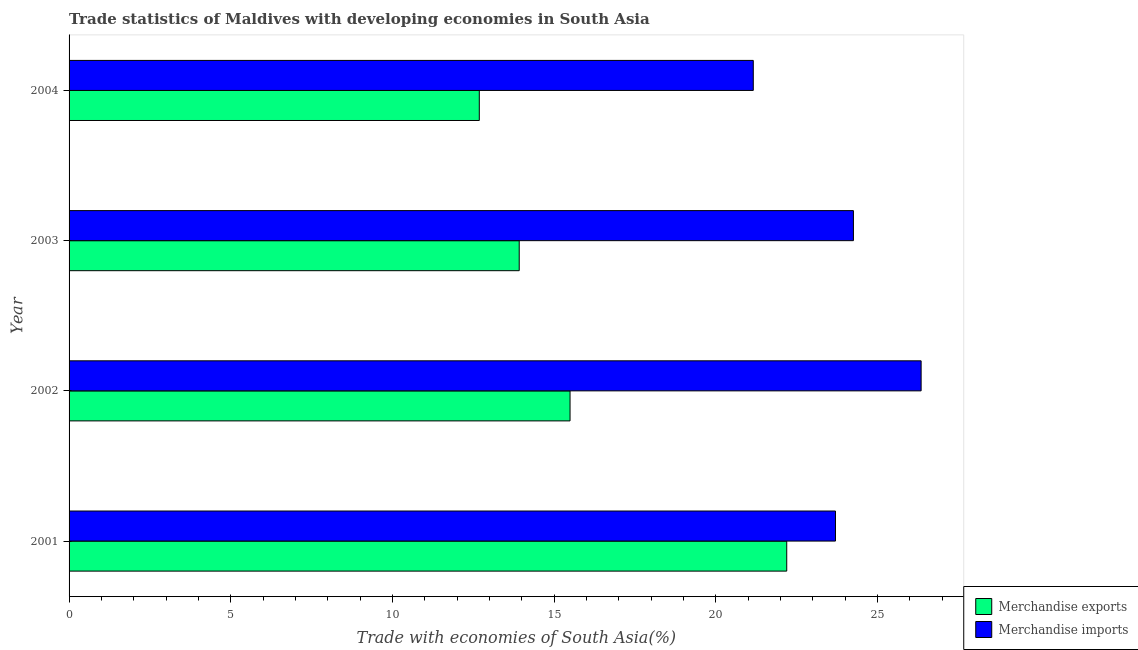How many groups of bars are there?
Provide a short and direct response. 4. Are the number of bars per tick equal to the number of legend labels?
Provide a succinct answer. Yes. Are the number of bars on each tick of the Y-axis equal?
Keep it short and to the point. Yes. How many bars are there on the 3rd tick from the top?
Your answer should be very brief. 2. How many bars are there on the 1st tick from the bottom?
Make the answer very short. 2. In how many cases, is the number of bars for a given year not equal to the number of legend labels?
Your response must be concise. 0. What is the merchandise exports in 2004?
Offer a terse response. 12.69. Across all years, what is the maximum merchandise exports?
Ensure brevity in your answer.  22.2. Across all years, what is the minimum merchandise exports?
Make the answer very short. 12.69. In which year was the merchandise imports maximum?
Make the answer very short. 2002. In which year was the merchandise exports minimum?
Your response must be concise. 2004. What is the total merchandise imports in the graph?
Provide a succinct answer. 95.48. What is the difference between the merchandise exports in 2003 and that in 2004?
Your response must be concise. 1.24. What is the difference between the merchandise exports in 2004 and the merchandise imports in 2001?
Your response must be concise. -11.02. What is the average merchandise exports per year?
Keep it short and to the point. 16.07. In the year 2004, what is the difference between the merchandise exports and merchandise imports?
Your response must be concise. -8.47. In how many years, is the merchandise exports greater than 21 %?
Your answer should be compact. 1. What is the ratio of the merchandise imports in 2002 to that in 2004?
Your response must be concise. 1.25. What is the difference between the highest and the second highest merchandise exports?
Offer a terse response. 6.7. What is the difference between the highest and the lowest merchandise imports?
Provide a short and direct response. 5.19. In how many years, is the merchandise imports greater than the average merchandise imports taken over all years?
Keep it short and to the point. 2. Is the sum of the merchandise imports in 2001 and 2003 greater than the maximum merchandise exports across all years?
Ensure brevity in your answer.  Yes. What does the 1st bar from the top in 2002 represents?
Your answer should be compact. Merchandise imports. What does the 1st bar from the bottom in 2001 represents?
Your response must be concise. Merchandise exports. What is the difference between two consecutive major ticks on the X-axis?
Ensure brevity in your answer.  5. Are the values on the major ticks of X-axis written in scientific E-notation?
Your answer should be compact. No. What is the title of the graph?
Keep it short and to the point. Trade statistics of Maldives with developing economies in South Asia. What is the label or title of the X-axis?
Offer a very short reply. Trade with economies of South Asia(%). What is the label or title of the Y-axis?
Ensure brevity in your answer.  Year. What is the Trade with economies of South Asia(%) of Merchandise exports in 2001?
Offer a very short reply. 22.2. What is the Trade with economies of South Asia(%) of Merchandise imports in 2001?
Ensure brevity in your answer.  23.7. What is the Trade with economies of South Asia(%) of Merchandise exports in 2002?
Keep it short and to the point. 15.49. What is the Trade with economies of South Asia(%) in Merchandise imports in 2002?
Your response must be concise. 26.35. What is the Trade with economies of South Asia(%) in Merchandise exports in 2003?
Offer a terse response. 13.92. What is the Trade with economies of South Asia(%) of Merchandise imports in 2003?
Your answer should be very brief. 24.26. What is the Trade with economies of South Asia(%) in Merchandise exports in 2004?
Your response must be concise. 12.69. What is the Trade with economies of South Asia(%) in Merchandise imports in 2004?
Give a very brief answer. 21.16. Across all years, what is the maximum Trade with economies of South Asia(%) in Merchandise exports?
Offer a terse response. 22.2. Across all years, what is the maximum Trade with economies of South Asia(%) in Merchandise imports?
Keep it short and to the point. 26.35. Across all years, what is the minimum Trade with economies of South Asia(%) of Merchandise exports?
Provide a short and direct response. 12.69. Across all years, what is the minimum Trade with economies of South Asia(%) of Merchandise imports?
Your answer should be very brief. 21.16. What is the total Trade with economies of South Asia(%) of Merchandise exports in the graph?
Your answer should be very brief. 64.3. What is the total Trade with economies of South Asia(%) in Merchandise imports in the graph?
Your response must be concise. 95.48. What is the difference between the Trade with economies of South Asia(%) in Merchandise exports in 2001 and that in 2002?
Ensure brevity in your answer.  6.7. What is the difference between the Trade with economies of South Asia(%) in Merchandise imports in 2001 and that in 2002?
Offer a terse response. -2.65. What is the difference between the Trade with economies of South Asia(%) of Merchandise exports in 2001 and that in 2003?
Make the answer very short. 8.27. What is the difference between the Trade with economies of South Asia(%) in Merchandise imports in 2001 and that in 2003?
Offer a very short reply. -0.56. What is the difference between the Trade with economies of South Asia(%) of Merchandise exports in 2001 and that in 2004?
Your answer should be very brief. 9.51. What is the difference between the Trade with economies of South Asia(%) of Merchandise imports in 2001 and that in 2004?
Offer a very short reply. 2.54. What is the difference between the Trade with economies of South Asia(%) of Merchandise exports in 2002 and that in 2003?
Keep it short and to the point. 1.57. What is the difference between the Trade with economies of South Asia(%) of Merchandise imports in 2002 and that in 2003?
Your response must be concise. 2.09. What is the difference between the Trade with economies of South Asia(%) of Merchandise exports in 2002 and that in 2004?
Ensure brevity in your answer.  2.81. What is the difference between the Trade with economies of South Asia(%) in Merchandise imports in 2002 and that in 2004?
Provide a short and direct response. 5.19. What is the difference between the Trade with economies of South Asia(%) of Merchandise exports in 2003 and that in 2004?
Keep it short and to the point. 1.23. What is the difference between the Trade with economies of South Asia(%) of Merchandise imports in 2003 and that in 2004?
Your answer should be very brief. 3.1. What is the difference between the Trade with economies of South Asia(%) in Merchandise exports in 2001 and the Trade with economies of South Asia(%) in Merchandise imports in 2002?
Your answer should be very brief. -4.16. What is the difference between the Trade with economies of South Asia(%) of Merchandise exports in 2001 and the Trade with economies of South Asia(%) of Merchandise imports in 2003?
Give a very brief answer. -2.06. What is the difference between the Trade with economies of South Asia(%) in Merchandise exports in 2001 and the Trade with economies of South Asia(%) in Merchandise imports in 2004?
Keep it short and to the point. 1.03. What is the difference between the Trade with economies of South Asia(%) in Merchandise exports in 2002 and the Trade with economies of South Asia(%) in Merchandise imports in 2003?
Your answer should be very brief. -8.76. What is the difference between the Trade with economies of South Asia(%) of Merchandise exports in 2002 and the Trade with economies of South Asia(%) of Merchandise imports in 2004?
Provide a succinct answer. -5.67. What is the difference between the Trade with economies of South Asia(%) of Merchandise exports in 2003 and the Trade with economies of South Asia(%) of Merchandise imports in 2004?
Make the answer very short. -7.24. What is the average Trade with economies of South Asia(%) of Merchandise exports per year?
Your answer should be compact. 16.08. What is the average Trade with economies of South Asia(%) in Merchandise imports per year?
Ensure brevity in your answer.  23.87. In the year 2001, what is the difference between the Trade with economies of South Asia(%) in Merchandise exports and Trade with economies of South Asia(%) in Merchandise imports?
Ensure brevity in your answer.  -1.51. In the year 2002, what is the difference between the Trade with economies of South Asia(%) of Merchandise exports and Trade with economies of South Asia(%) of Merchandise imports?
Your response must be concise. -10.86. In the year 2003, what is the difference between the Trade with economies of South Asia(%) in Merchandise exports and Trade with economies of South Asia(%) in Merchandise imports?
Your answer should be compact. -10.34. In the year 2004, what is the difference between the Trade with economies of South Asia(%) in Merchandise exports and Trade with economies of South Asia(%) in Merchandise imports?
Provide a succinct answer. -8.47. What is the ratio of the Trade with economies of South Asia(%) of Merchandise exports in 2001 to that in 2002?
Keep it short and to the point. 1.43. What is the ratio of the Trade with economies of South Asia(%) of Merchandise imports in 2001 to that in 2002?
Provide a short and direct response. 0.9. What is the ratio of the Trade with economies of South Asia(%) in Merchandise exports in 2001 to that in 2003?
Keep it short and to the point. 1.59. What is the ratio of the Trade with economies of South Asia(%) in Merchandise imports in 2001 to that in 2003?
Offer a terse response. 0.98. What is the ratio of the Trade with economies of South Asia(%) in Merchandise exports in 2001 to that in 2004?
Offer a very short reply. 1.75. What is the ratio of the Trade with economies of South Asia(%) in Merchandise imports in 2001 to that in 2004?
Provide a short and direct response. 1.12. What is the ratio of the Trade with economies of South Asia(%) of Merchandise exports in 2002 to that in 2003?
Provide a short and direct response. 1.11. What is the ratio of the Trade with economies of South Asia(%) of Merchandise imports in 2002 to that in 2003?
Make the answer very short. 1.09. What is the ratio of the Trade with economies of South Asia(%) in Merchandise exports in 2002 to that in 2004?
Provide a succinct answer. 1.22. What is the ratio of the Trade with economies of South Asia(%) of Merchandise imports in 2002 to that in 2004?
Your answer should be very brief. 1.25. What is the ratio of the Trade with economies of South Asia(%) of Merchandise exports in 2003 to that in 2004?
Make the answer very short. 1.1. What is the ratio of the Trade with economies of South Asia(%) in Merchandise imports in 2003 to that in 2004?
Provide a succinct answer. 1.15. What is the difference between the highest and the second highest Trade with economies of South Asia(%) of Merchandise exports?
Your response must be concise. 6.7. What is the difference between the highest and the second highest Trade with economies of South Asia(%) of Merchandise imports?
Offer a terse response. 2.09. What is the difference between the highest and the lowest Trade with economies of South Asia(%) in Merchandise exports?
Your response must be concise. 9.51. What is the difference between the highest and the lowest Trade with economies of South Asia(%) in Merchandise imports?
Give a very brief answer. 5.19. 